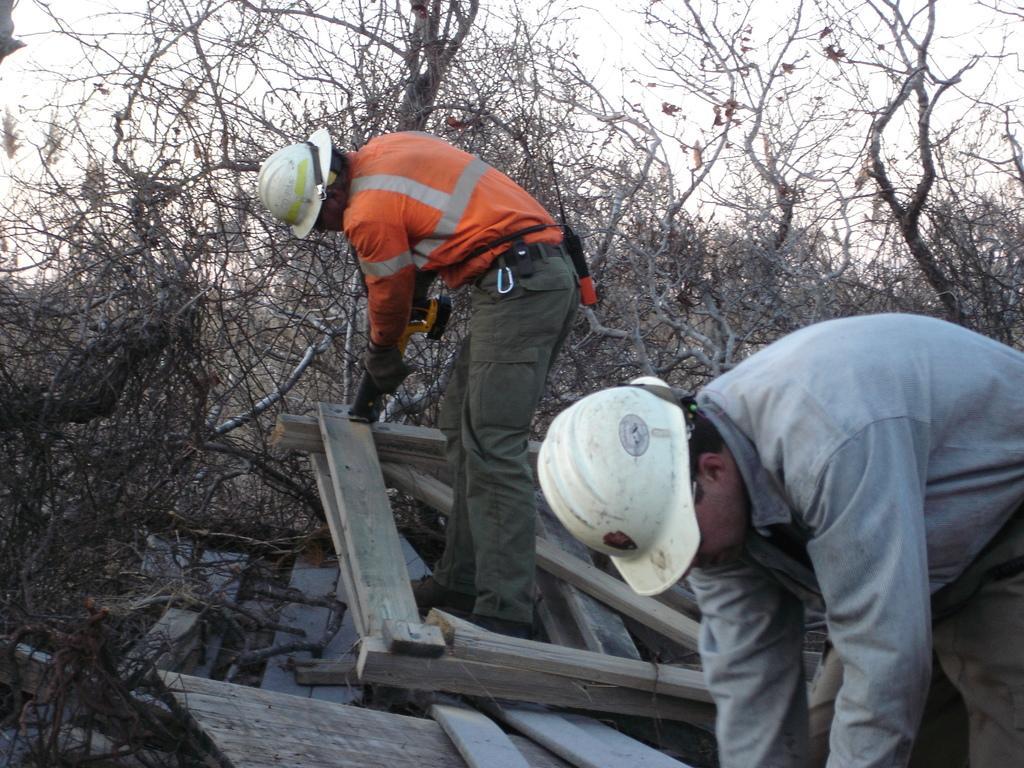Describe this image in one or two sentences. In the center of the image we can see a man is standing and wearing jacket, hat and holding an object. In the bottom right corner we can see a man is bending and wearing a cap. In the background of the image we can see the dry trees. At the bottom of the image we can see the wood. At the top of the image we can see the sky. 